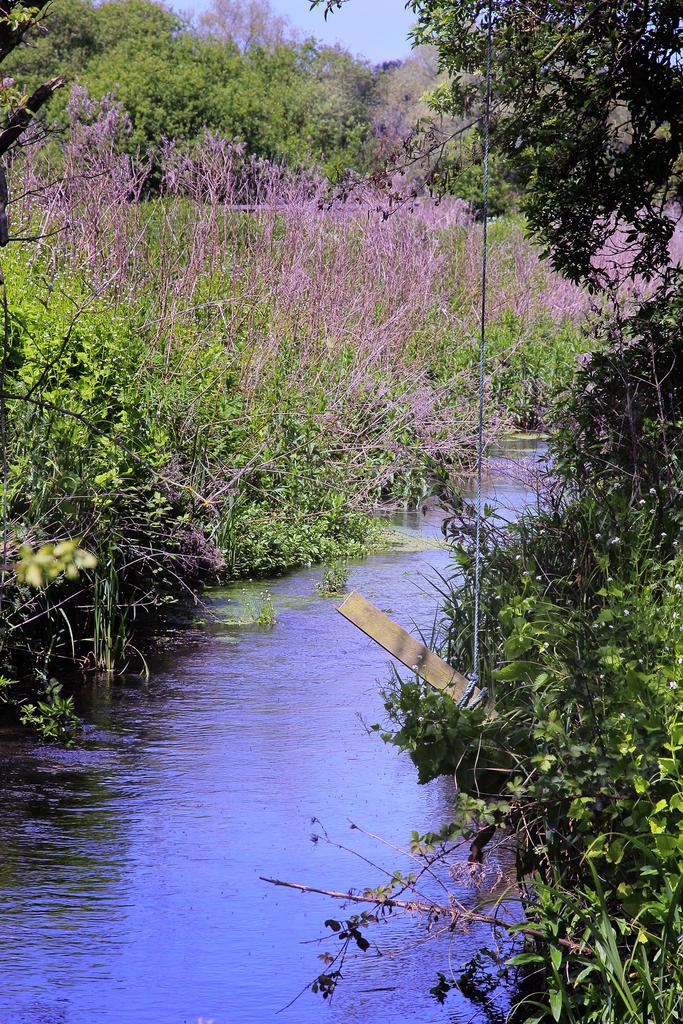What is the primary element visible in the image? There is water in the image. What type of vegetation can be seen in the image? There are trees in the image. What object is tied with a rope in the image? There is a wooden stick tied with a rope in the image. What can be seen in the background of the image? The sky is visible in the background of the image. What type of wilderness show is taking place in the image? There is no show or event depicted in the image; it simply shows water, trees, a wooden stick tied with a rope, and the sky. How many people are walking in the image? There are no people visible in the image, so it is not possible to determine how many people might be walking. 